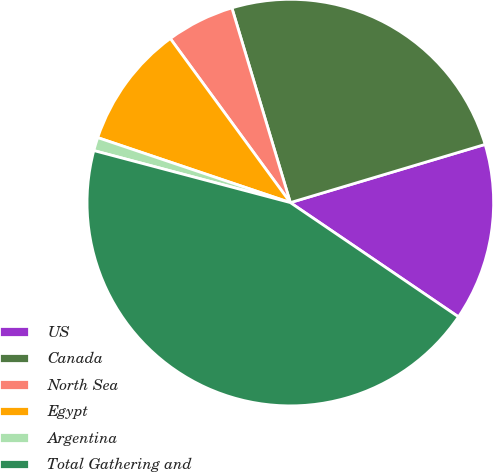Convert chart. <chart><loc_0><loc_0><loc_500><loc_500><pie_chart><fcel>US<fcel>Canada<fcel>North Sea<fcel>Egypt<fcel>Argentina<fcel>Total Gathering and<nl><fcel>14.12%<fcel>25.02%<fcel>5.41%<fcel>9.77%<fcel>1.06%<fcel>44.62%<nl></chart> 